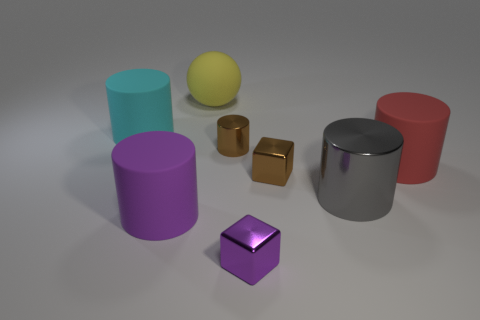Subtract all gray cylinders. How many cylinders are left? 4 Subtract all tiny brown metal cylinders. How many cylinders are left? 4 Subtract all blue cylinders. Subtract all blue balls. How many cylinders are left? 5 Add 1 cubes. How many objects exist? 9 Subtract all blocks. How many objects are left? 6 Subtract 0 blue spheres. How many objects are left? 8 Subtract all tiny objects. Subtract all large yellow things. How many objects are left? 4 Add 6 brown metallic cylinders. How many brown metallic cylinders are left? 7 Add 5 metallic things. How many metallic things exist? 9 